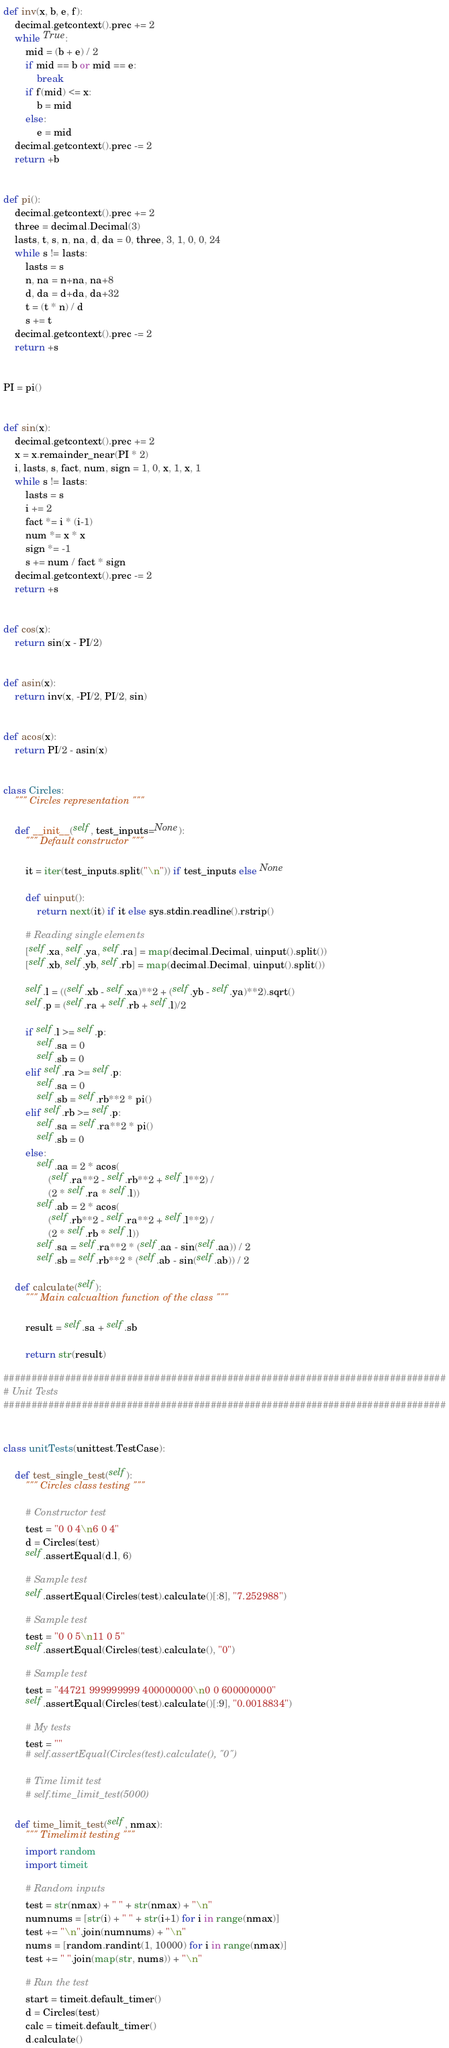Convert code to text. <code><loc_0><loc_0><loc_500><loc_500><_Python_>
def inv(x, b, e, f):
    decimal.getcontext().prec += 2
    while True:
        mid = (b + e) / 2
        if mid == b or mid == e:
            break
        if f(mid) <= x:
            b = mid
        else:
            e = mid
    decimal.getcontext().prec -= 2
    return +b


def pi():
    decimal.getcontext().prec += 2
    three = decimal.Decimal(3)
    lasts, t, s, n, na, d, da = 0, three, 3, 1, 0, 0, 24
    while s != lasts:
        lasts = s
        n, na = n+na, na+8
        d, da = d+da, da+32
        t = (t * n) / d
        s += t
    decimal.getcontext().prec -= 2
    return +s


PI = pi()


def sin(x):
    decimal.getcontext().prec += 2
    x = x.remainder_near(PI * 2)
    i, lasts, s, fact, num, sign = 1, 0, x, 1, x, 1
    while s != lasts:
        lasts = s
        i += 2
        fact *= i * (i-1)
        num *= x * x
        sign *= -1
        s += num / fact * sign
    decimal.getcontext().prec -= 2
    return +s


def cos(x):
    return sin(x - PI/2)


def asin(x):
    return inv(x, -PI/2, PI/2, sin)


def acos(x):
    return PI/2 - asin(x)


class Circles:
    """ Circles representation """

    def __init__(self, test_inputs=None):
        """ Default constructor """

        it = iter(test_inputs.split("\n")) if test_inputs else None

        def uinput():
            return next(it) if it else sys.stdin.readline().rstrip()

        # Reading single elements
        [self.xa, self.ya, self.ra] = map(decimal.Decimal, uinput().split())
        [self.xb, self.yb, self.rb] = map(decimal.Decimal, uinput().split())

        self.l = ((self.xb - self.xa)**2 + (self.yb - self.ya)**2).sqrt()
        self.p = (self.ra + self.rb + self.l)/2

        if self.l >= self.p:
            self.sa = 0
            self.sb = 0
        elif self.ra >= self.p:
            self.sa = 0
            self.sb = self.rb**2 * pi()
        elif self.rb >= self.p:
            self.sa = self.ra**2 * pi()
            self.sb = 0
        else:
            self.aa = 2 * acos(
                (self.ra**2 - self.rb**2 + self.l**2) /
                (2 * self.ra * self.l))
            self.ab = 2 * acos(
                (self.rb**2 - self.ra**2 + self.l**2) /
                (2 * self.rb * self.l))
            self.sa = self.ra**2 * (self.aa - sin(self.aa)) / 2
            self.sb = self.rb**2 * (self.ab - sin(self.ab)) / 2

    def calculate(self):
        """ Main calcualtion function of the class """

        result = self.sa + self.sb

        return str(result)

###############################################################################
# Unit Tests
###############################################################################


class unitTests(unittest.TestCase):

    def test_single_test(self):
        """ Circles class testing """

        # Constructor test
        test = "0 0 4\n6 0 4"
        d = Circles(test)
        self.assertEqual(d.l, 6)

        # Sample test
        self.assertEqual(Circles(test).calculate()[:8], "7.252988")

        # Sample test
        test = "0 0 5\n11 0 5"
        self.assertEqual(Circles(test).calculate(), "0")

        # Sample test
        test = "44721 999999999 400000000\n0 0 600000000"
        self.assertEqual(Circles(test).calculate()[:9], "0.0018834")

        # My tests
        test = ""
        # self.assertEqual(Circles(test).calculate(), "0")

        # Time limit test
        # self.time_limit_test(5000)

    def time_limit_test(self, nmax):
        """ Timelimit testing """
        import random
        import timeit

        # Random inputs
        test = str(nmax) + " " + str(nmax) + "\n"
        numnums = [str(i) + " " + str(i+1) for i in range(nmax)]
        test += "\n".join(numnums) + "\n"
        nums = [random.randint(1, 10000) for i in range(nmax)]
        test += " ".join(map(str, nums)) + "\n"

        # Run the test
        start = timeit.default_timer()
        d = Circles(test)
        calc = timeit.default_timer()
        d.calculate()</code> 